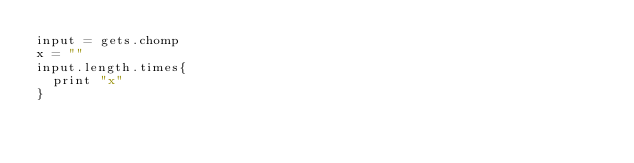Convert code to text. <code><loc_0><loc_0><loc_500><loc_500><_Ruby_>input = gets.chomp
x = ""
input.length.times{
  print "x"
}</code> 